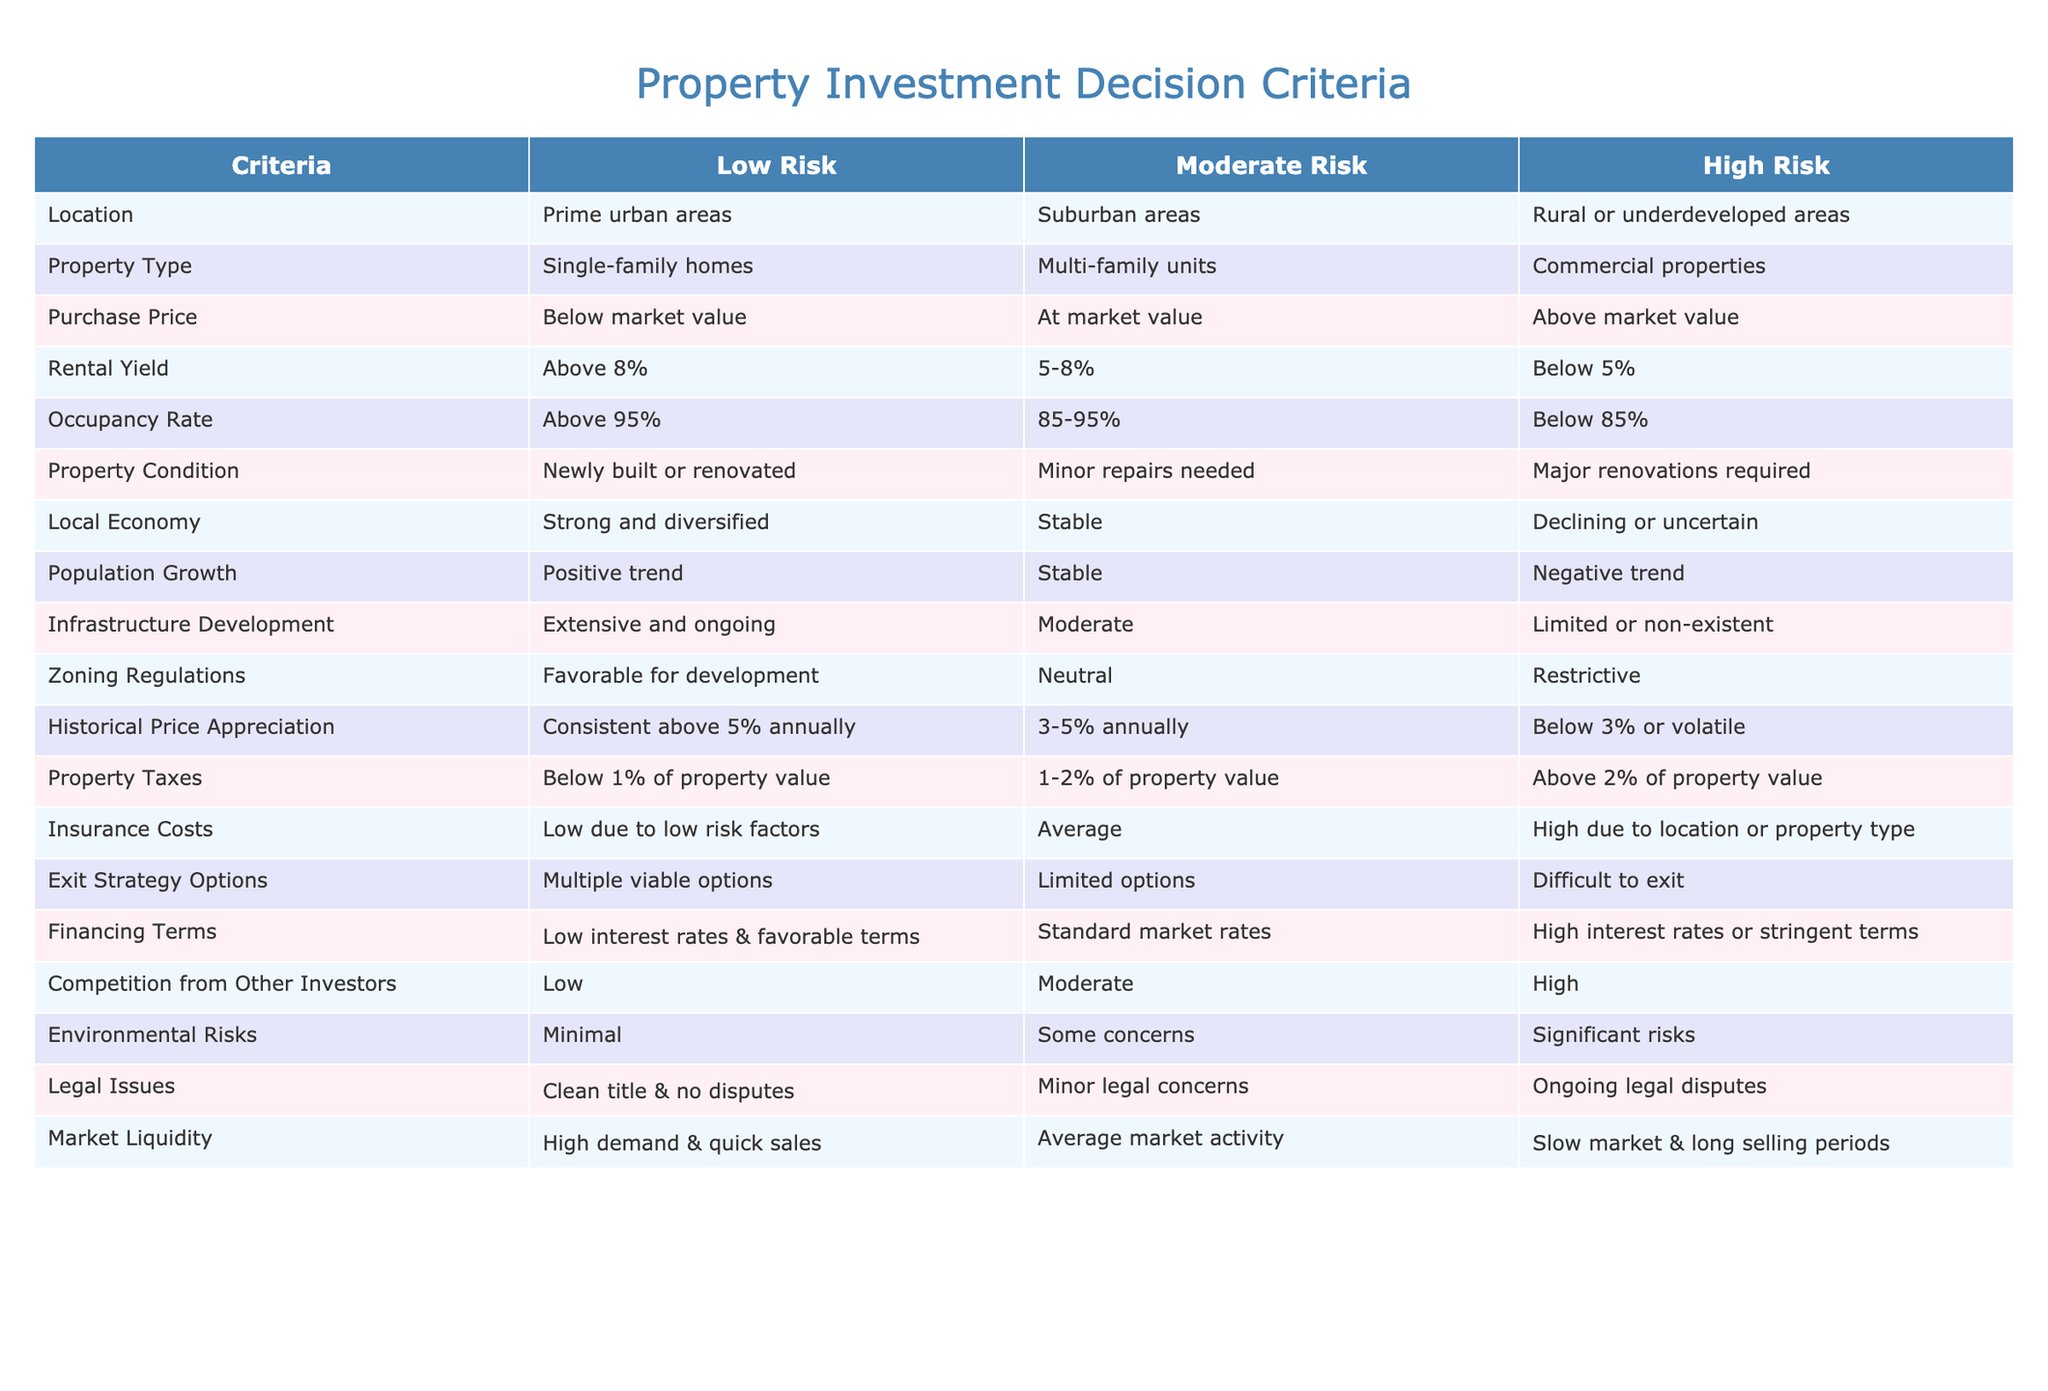What types of properties are considered low risk for investment? According to the table, low-risk property types include single-family homes. This is directly stated in the "Property Type" row under the "Low Risk" column.
Answer: Single-family homes Which location is categorized as high risk? The table indicates that rural or underdeveloped areas fall under the "High Risk" classification in the "Location" row.
Answer: Rural or underdeveloped areas Is the average rental yield for moderate risk properties above 5%? The average rental yield for moderate risk is stated as 5-8% in the "Rental Yield" row. Since the minimum is 5%, it confirms that it is above 5%.
Answer: Yes What is the difference in property tax rates between low risk and high risk? The property tax for low risk is below 1% of property value, while for high risk it is above 2%. Therefore, the difference is more than 1%.
Answer: More than 1% If a property has a strong local economy and is newly built, what is the risk level? A strong and diversified local economy aligns with low risk, and being newly built also categorizes it as low risk in the "Property Condition" row. Therefore, these factors indicate that the property presents low risk.
Answer: Low risk What are the potential zoning regulations for moderate risk properties? The zoning regulations for moderate risk properties are mentioned as neutral, which stresses that there are neither particularly favorable nor unfavorable regulations affecting these properties.
Answer: Neutral What is the minimum occupancy rate for moderate risk investments? According to the table, the occupancy rate for moderate risk is between 85% and 95%. The minimum indicated is 85%.
Answer: 85% Is a property with a historical price appreciation rate of 3% considered low risk? The table states low risk properties consistently show appreciation above 5% annually. Thus, a property with 3% appreciation does not meet the low-risk criteria.
Answer: No What can be inferred about the exit strategy options for high risk properties? The exit strategy options for high-risk properties are categorized as difficult to exit based on the "Exit Strategy Options" row, indicating challenges in selling or liquidating such investments.
Answer: Difficult to exit 